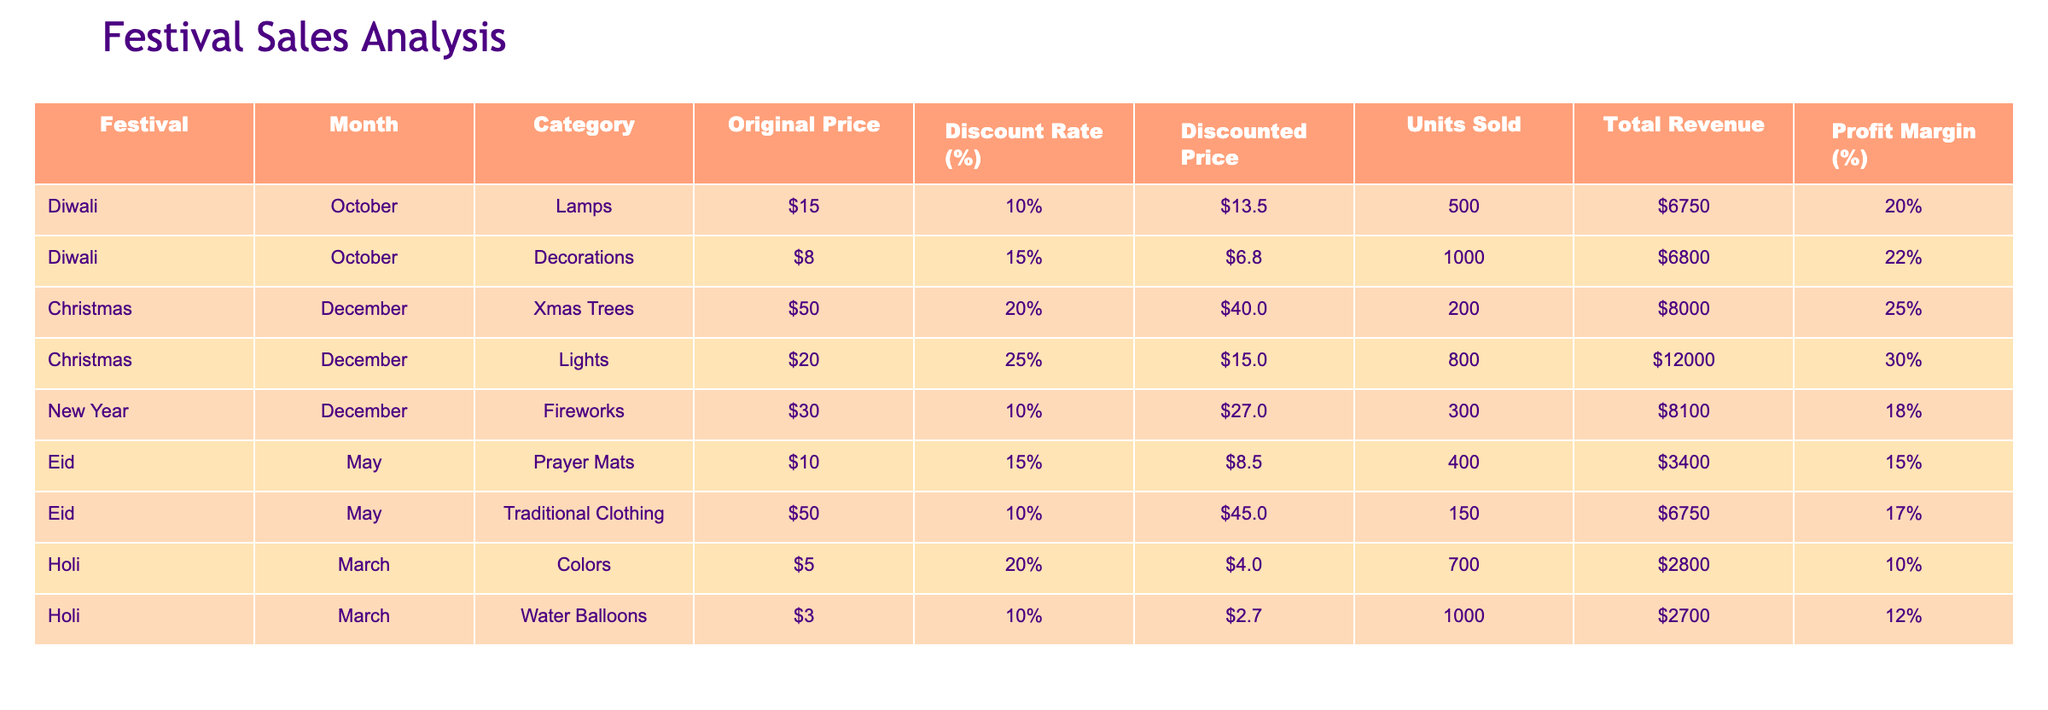What is the total revenue generated from the "Xmas Trees" category during Christmas? From the table, the "Total Revenue" for the "Xmas Trees" category in December is listed as $8000.
Answer: $8000 Which festival had the highest number of units sold for decorations? According to the table, the "Decorations" category for Diwali in October had 1000 units sold, which is higher than any other festival's decoration sales.
Answer: Diwali What is the profit margin for lamps sold during Diwali? The profit margin percentage for lamps is listed as 20% in the table.
Answer: 20% Did the "Fireworks" category have a higher discount rate than the "Xmas Trees" category? The discount rate for "Fireworks" is 10% and for "Xmas Trees" is 20%. Therefore, "Xmas Trees" had a higher discount rate.
Answer: No What is the average discounted price across all festival categories? The discounted prices are $13.5, $6.8, $40, $15, $27, $8.5, $45, $4, $2.7. Calculating the average: (13.5 + 6.8 + 40 + 15 + 27 + 8.5 + 45 + 4 + 2.7) / 9 = 15.82 (approximately).
Answer: $15.82 How much total revenue did the "Water Balloons" category bring in? The total revenue for "Water Balloons" is shown as $2700 in the table.
Answer: $2700 Was the total revenue from "Prayer Mats" lower than that from "Traditional Clothing"? The total revenue for "Prayer Mats" is $3400, and for "Traditional Clothing," it is $6750. Since $3400 is less than $6750, the statement is true.
Answer: Yes What is the profit margin difference between "Christmas Lights" and "Diwali Decorations"? The profit margin for "Christmas Lights" is 30% and for "Diwali Decorations" is 22%. The difference is 30% - 22% = 8%.
Answer: 8% 